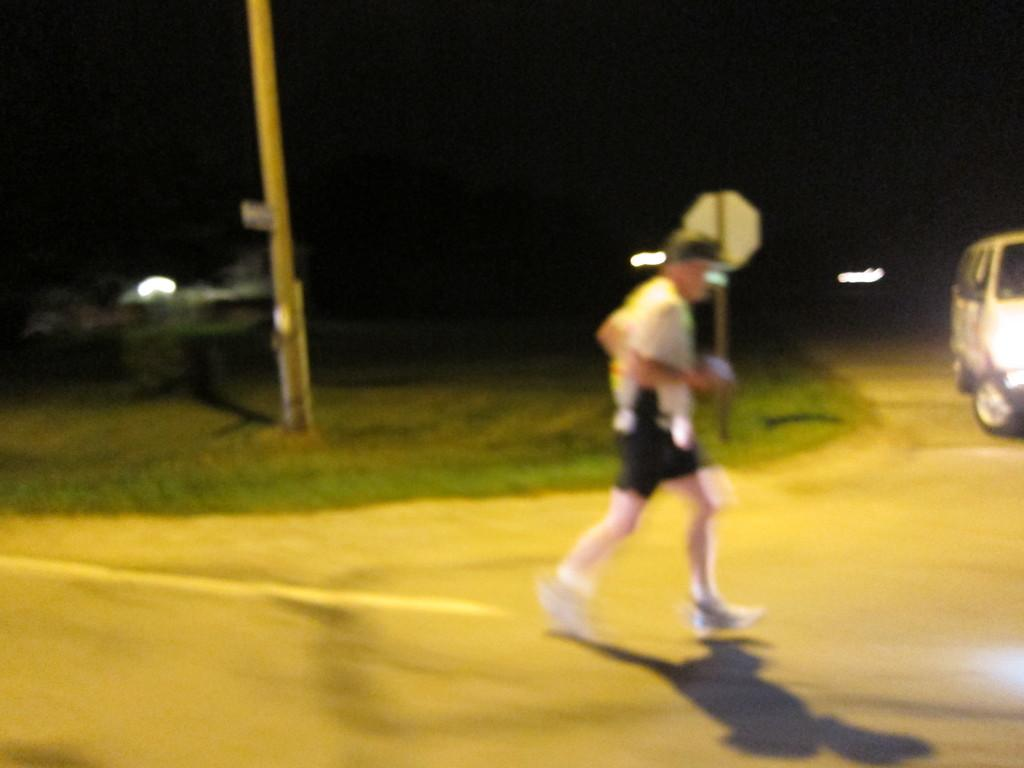What is the person in the image doing? There is a person walking on the road in the image. What can be seen in the background of the image? There is a pole, grass, a sign board, a road, and a motor vehicle in the background of the image. Where is the stove located in the image? There is no stove present in the image. What type of plant can be seen growing on the road in the image? There are no plants growing on the road in the image. 